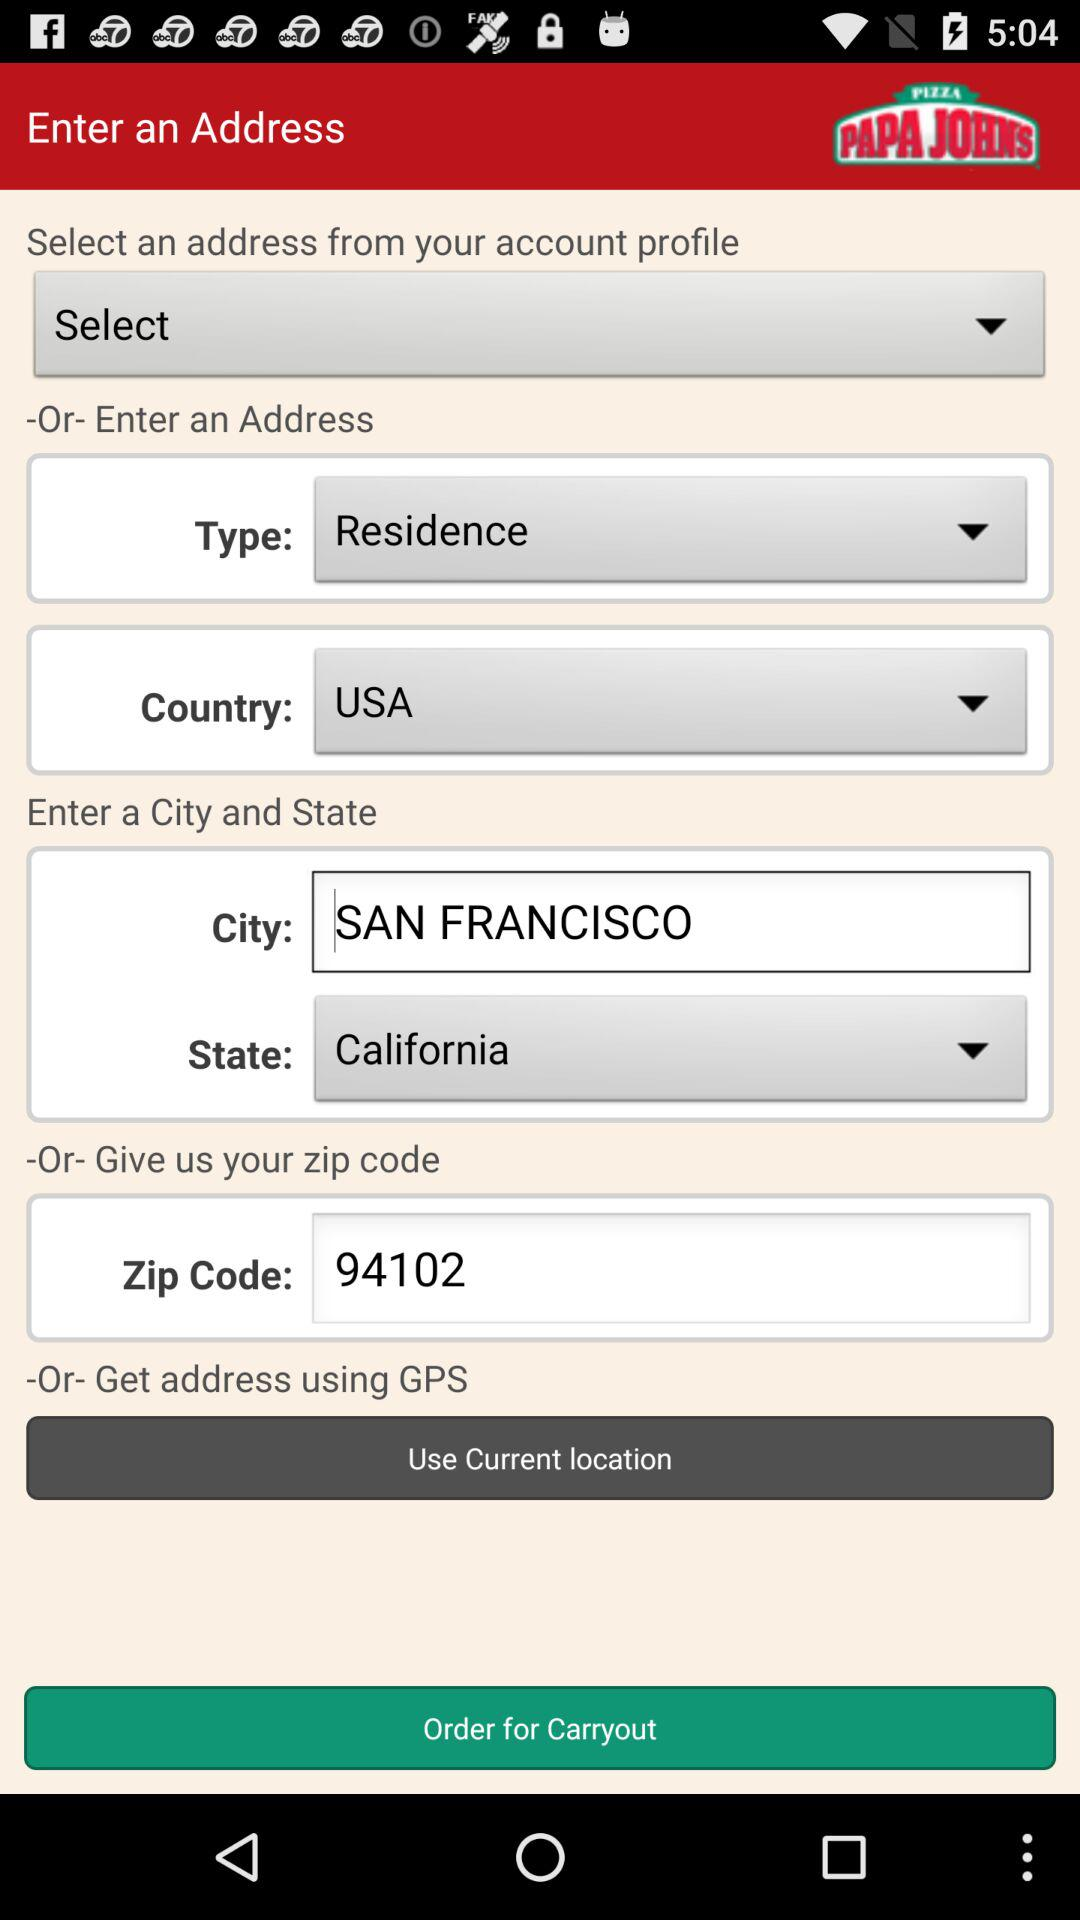What is the city name? The city name is San Francisco. 